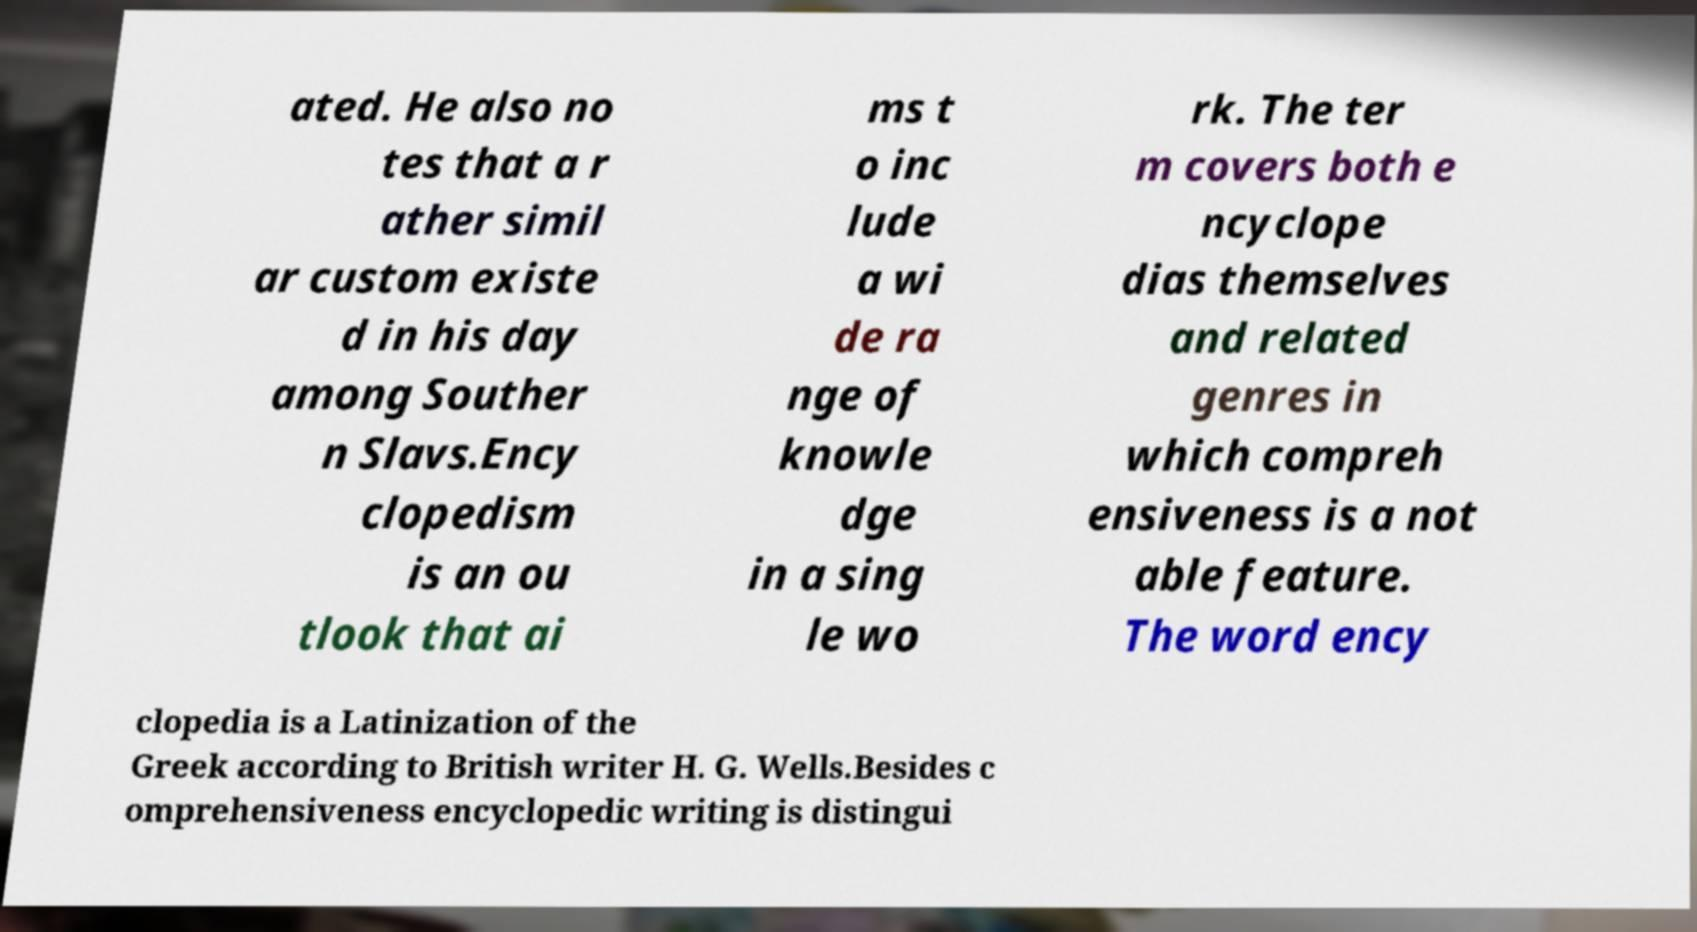Could you extract and type out the text from this image? ated. He also no tes that a r ather simil ar custom existe d in his day among Souther n Slavs.Ency clopedism is an ou tlook that ai ms t o inc lude a wi de ra nge of knowle dge in a sing le wo rk. The ter m covers both e ncyclope dias themselves and related genres in which compreh ensiveness is a not able feature. The word ency clopedia is a Latinization of the Greek according to British writer H. G. Wells.Besides c omprehensiveness encyclopedic writing is distingui 